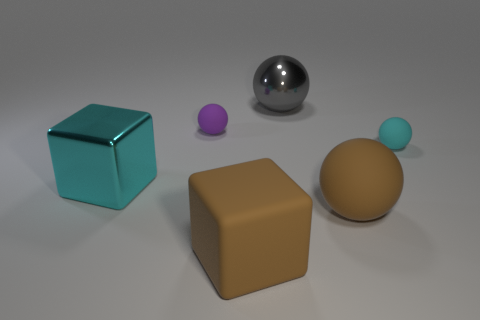Subtract all brown spheres. How many spheres are left? 3 Subtract all gray metal spheres. How many spheres are left? 3 Subtract all yellow balls. Subtract all cyan cubes. How many balls are left? 4 Add 3 brown rubber blocks. How many objects exist? 9 Subtract all balls. How many objects are left? 2 Add 3 small objects. How many small objects exist? 5 Subtract 0 yellow spheres. How many objects are left? 6 Subtract all big balls. Subtract all cubes. How many objects are left? 2 Add 2 gray shiny things. How many gray shiny things are left? 3 